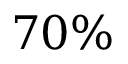Convert formula to latex. <formula><loc_0><loc_0><loc_500><loc_500>7 0 \%</formula> 